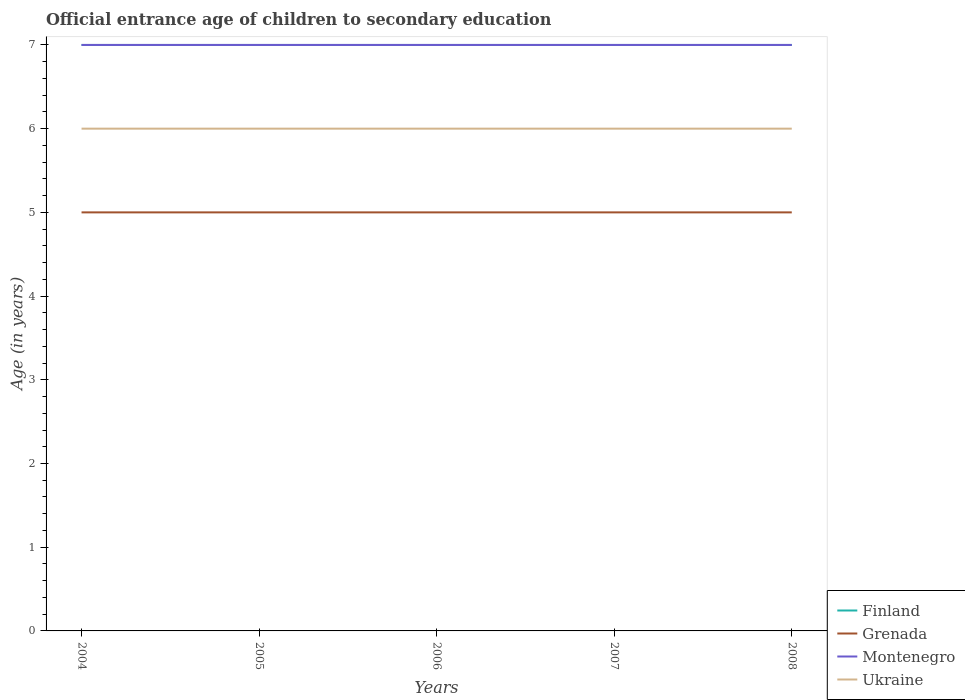How many different coloured lines are there?
Make the answer very short. 4. Across all years, what is the maximum secondary school starting age of children in Finland?
Ensure brevity in your answer.  7. What is the total secondary school starting age of children in Grenada in the graph?
Give a very brief answer. 0. What is the difference between the highest and the lowest secondary school starting age of children in Ukraine?
Ensure brevity in your answer.  0. Is the secondary school starting age of children in Ukraine strictly greater than the secondary school starting age of children in Finland over the years?
Offer a terse response. Yes. How many lines are there?
Ensure brevity in your answer.  4. Are the values on the major ticks of Y-axis written in scientific E-notation?
Your answer should be compact. No. Does the graph contain any zero values?
Ensure brevity in your answer.  No. What is the title of the graph?
Your response must be concise. Official entrance age of children to secondary education. What is the label or title of the Y-axis?
Ensure brevity in your answer.  Age (in years). What is the Age (in years) of Finland in 2004?
Your answer should be very brief. 7. What is the Age (in years) of Montenegro in 2004?
Give a very brief answer. 7. What is the Age (in years) of Grenada in 2005?
Offer a terse response. 5. What is the Age (in years) of Grenada in 2006?
Give a very brief answer. 5. What is the Age (in years) in Grenada in 2007?
Ensure brevity in your answer.  5. What is the Age (in years) of Montenegro in 2007?
Ensure brevity in your answer.  7. What is the Age (in years) in Ukraine in 2007?
Offer a very short reply. 6. What is the Age (in years) in Grenada in 2008?
Offer a terse response. 5. What is the Age (in years) of Ukraine in 2008?
Your answer should be very brief. 6. Across all years, what is the maximum Age (in years) of Grenada?
Give a very brief answer. 5. Across all years, what is the maximum Age (in years) of Montenegro?
Make the answer very short. 7. Across all years, what is the maximum Age (in years) of Ukraine?
Provide a short and direct response. 6. Across all years, what is the minimum Age (in years) of Finland?
Offer a very short reply. 7. What is the total Age (in years) in Finland in the graph?
Your answer should be compact. 35. What is the total Age (in years) in Montenegro in the graph?
Your answer should be very brief. 35. What is the difference between the Age (in years) of Grenada in 2004 and that in 2005?
Ensure brevity in your answer.  0. What is the difference between the Age (in years) in Montenegro in 2004 and that in 2005?
Your answer should be very brief. 0. What is the difference between the Age (in years) of Ukraine in 2004 and that in 2005?
Provide a short and direct response. 0. What is the difference between the Age (in years) in Finland in 2004 and that in 2006?
Provide a succinct answer. 0. What is the difference between the Age (in years) in Grenada in 2004 and that in 2006?
Make the answer very short. 0. What is the difference between the Age (in years) of Montenegro in 2004 and that in 2006?
Give a very brief answer. 0. What is the difference between the Age (in years) in Finland in 2005 and that in 2006?
Ensure brevity in your answer.  0. What is the difference between the Age (in years) in Grenada in 2005 and that in 2006?
Your answer should be compact. 0. What is the difference between the Age (in years) of Finland in 2005 and that in 2007?
Make the answer very short. 0. What is the difference between the Age (in years) of Ukraine in 2005 and that in 2007?
Your answer should be compact. 0. What is the difference between the Age (in years) of Finland in 2006 and that in 2007?
Ensure brevity in your answer.  0. What is the difference between the Age (in years) of Grenada in 2006 and that in 2007?
Your response must be concise. 0. What is the difference between the Age (in years) of Grenada in 2006 and that in 2008?
Ensure brevity in your answer.  0. What is the difference between the Age (in years) of Ukraine in 2006 and that in 2008?
Provide a short and direct response. 0. What is the difference between the Age (in years) of Finland in 2007 and that in 2008?
Ensure brevity in your answer.  0. What is the difference between the Age (in years) of Montenegro in 2007 and that in 2008?
Make the answer very short. 0. What is the difference between the Age (in years) in Finland in 2004 and the Age (in years) in Grenada in 2005?
Provide a succinct answer. 2. What is the difference between the Age (in years) of Grenada in 2004 and the Age (in years) of Ukraine in 2005?
Make the answer very short. -1. What is the difference between the Age (in years) in Grenada in 2004 and the Age (in years) in Montenegro in 2006?
Ensure brevity in your answer.  -2. What is the difference between the Age (in years) of Finland in 2004 and the Age (in years) of Grenada in 2007?
Offer a very short reply. 2. What is the difference between the Age (in years) of Montenegro in 2004 and the Age (in years) of Ukraine in 2007?
Offer a terse response. 1. What is the difference between the Age (in years) in Finland in 2004 and the Age (in years) in Grenada in 2008?
Your answer should be very brief. 2. What is the difference between the Age (in years) of Finland in 2004 and the Age (in years) of Montenegro in 2008?
Provide a succinct answer. 0. What is the difference between the Age (in years) of Finland in 2004 and the Age (in years) of Ukraine in 2008?
Make the answer very short. 1. What is the difference between the Age (in years) of Grenada in 2004 and the Age (in years) of Ukraine in 2008?
Make the answer very short. -1. What is the difference between the Age (in years) of Montenegro in 2004 and the Age (in years) of Ukraine in 2008?
Your answer should be very brief. 1. What is the difference between the Age (in years) in Grenada in 2005 and the Age (in years) in Montenegro in 2006?
Your answer should be compact. -2. What is the difference between the Age (in years) in Finland in 2005 and the Age (in years) in Grenada in 2007?
Offer a terse response. 2. What is the difference between the Age (in years) of Finland in 2005 and the Age (in years) of Montenegro in 2007?
Keep it short and to the point. 0. What is the difference between the Age (in years) of Finland in 2005 and the Age (in years) of Ukraine in 2007?
Make the answer very short. 1. What is the difference between the Age (in years) in Finland in 2005 and the Age (in years) in Montenegro in 2008?
Ensure brevity in your answer.  0. What is the difference between the Age (in years) of Finland in 2005 and the Age (in years) of Ukraine in 2008?
Provide a short and direct response. 1. What is the difference between the Age (in years) in Grenada in 2005 and the Age (in years) in Montenegro in 2008?
Give a very brief answer. -2. What is the difference between the Age (in years) of Grenada in 2005 and the Age (in years) of Ukraine in 2008?
Give a very brief answer. -1. What is the difference between the Age (in years) in Montenegro in 2005 and the Age (in years) in Ukraine in 2008?
Provide a short and direct response. 1. What is the difference between the Age (in years) in Finland in 2006 and the Age (in years) in Montenegro in 2007?
Ensure brevity in your answer.  0. What is the difference between the Age (in years) of Grenada in 2006 and the Age (in years) of Ukraine in 2007?
Provide a short and direct response. -1. What is the difference between the Age (in years) of Montenegro in 2006 and the Age (in years) of Ukraine in 2007?
Keep it short and to the point. 1. What is the difference between the Age (in years) in Finland in 2006 and the Age (in years) in Ukraine in 2008?
Keep it short and to the point. 1. What is the difference between the Age (in years) in Grenada in 2006 and the Age (in years) in Ukraine in 2008?
Keep it short and to the point. -1. What is the difference between the Age (in years) in Montenegro in 2006 and the Age (in years) in Ukraine in 2008?
Keep it short and to the point. 1. What is the difference between the Age (in years) of Finland in 2007 and the Age (in years) of Grenada in 2008?
Provide a short and direct response. 2. What is the difference between the Age (in years) of Finland in 2007 and the Age (in years) of Montenegro in 2008?
Your answer should be compact. 0. What is the difference between the Age (in years) of Grenada in 2007 and the Age (in years) of Montenegro in 2008?
Keep it short and to the point. -2. What is the difference between the Age (in years) in Grenada in 2007 and the Age (in years) in Ukraine in 2008?
Ensure brevity in your answer.  -1. What is the difference between the Age (in years) of Montenegro in 2007 and the Age (in years) of Ukraine in 2008?
Provide a succinct answer. 1. What is the average Age (in years) in Finland per year?
Ensure brevity in your answer.  7. What is the average Age (in years) of Montenegro per year?
Offer a very short reply. 7. What is the average Age (in years) of Ukraine per year?
Your answer should be compact. 6. In the year 2004, what is the difference between the Age (in years) in Finland and Age (in years) in Grenada?
Provide a succinct answer. 2. In the year 2004, what is the difference between the Age (in years) of Finland and Age (in years) of Montenegro?
Offer a very short reply. 0. In the year 2004, what is the difference between the Age (in years) of Finland and Age (in years) of Ukraine?
Give a very brief answer. 1. In the year 2004, what is the difference between the Age (in years) in Montenegro and Age (in years) in Ukraine?
Your response must be concise. 1. In the year 2005, what is the difference between the Age (in years) of Finland and Age (in years) of Ukraine?
Your response must be concise. 1. In the year 2005, what is the difference between the Age (in years) in Grenada and Age (in years) in Montenegro?
Your answer should be compact. -2. In the year 2005, what is the difference between the Age (in years) of Grenada and Age (in years) of Ukraine?
Provide a short and direct response. -1. In the year 2005, what is the difference between the Age (in years) in Montenegro and Age (in years) in Ukraine?
Provide a short and direct response. 1. In the year 2006, what is the difference between the Age (in years) in Finland and Age (in years) in Grenada?
Give a very brief answer. 2. In the year 2006, what is the difference between the Age (in years) of Finland and Age (in years) of Montenegro?
Give a very brief answer. 0. In the year 2006, what is the difference between the Age (in years) of Grenada and Age (in years) of Montenegro?
Provide a succinct answer. -2. In the year 2007, what is the difference between the Age (in years) of Finland and Age (in years) of Grenada?
Provide a succinct answer. 2. In the year 2007, what is the difference between the Age (in years) of Finland and Age (in years) of Montenegro?
Your answer should be very brief. 0. In the year 2007, what is the difference between the Age (in years) of Grenada and Age (in years) of Montenegro?
Keep it short and to the point. -2. In the year 2008, what is the difference between the Age (in years) in Finland and Age (in years) in Grenada?
Make the answer very short. 2. In the year 2008, what is the difference between the Age (in years) of Finland and Age (in years) of Montenegro?
Make the answer very short. 0. In the year 2008, what is the difference between the Age (in years) of Finland and Age (in years) of Ukraine?
Give a very brief answer. 1. In the year 2008, what is the difference between the Age (in years) of Montenegro and Age (in years) of Ukraine?
Your answer should be compact. 1. What is the ratio of the Age (in years) in Finland in 2004 to that in 2005?
Offer a very short reply. 1. What is the ratio of the Age (in years) in Montenegro in 2004 to that in 2005?
Your response must be concise. 1. What is the ratio of the Age (in years) of Grenada in 2004 to that in 2006?
Provide a succinct answer. 1. What is the ratio of the Age (in years) in Montenegro in 2004 to that in 2006?
Your answer should be compact. 1. What is the ratio of the Age (in years) in Finland in 2004 to that in 2007?
Keep it short and to the point. 1. What is the ratio of the Age (in years) of Grenada in 2004 to that in 2007?
Offer a terse response. 1. What is the ratio of the Age (in years) in Montenegro in 2004 to that in 2007?
Your answer should be compact. 1. What is the ratio of the Age (in years) of Montenegro in 2004 to that in 2008?
Provide a succinct answer. 1. What is the ratio of the Age (in years) in Ukraine in 2005 to that in 2006?
Provide a succinct answer. 1. What is the ratio of the Age (in years) in Grenada in 2005 to that in 2007?
Provide a short and direct response. 1. What is the ratio of the Age (in years) in Montenegro in 2005 to that in 2007?
Offer a very short reply. 1. What is the ratio of the Age (in years) in Finland in 2005 to that in 2008?
Give a very brief answer. 1. What is the ratio of the Age (in years) of Grenada in 2005 to that in 2008?
Your answer should be compact. 1. What is the ratio of the Age (in years) in Finland in 2006 to that in 2007?
Provide a succinct answer. 1. What is the ratio of the Age (in years) in Grenada in 2006 to that in 2007?
Provide a short and direct response. 1. What is the ratio of the Age (in years) in Ukraine in 2006 to that in 2007?
Keep it short and to the point. 1. What is the ratio of the Age (in years) of Montenegro in 2007 to that in 2008?
Make the answer very short. 1. What is the ratio of the Age (in years) in Ukraine in 2007 to that in 2008?
Ensure brevity in your answer.  1. What is the difference between the highest and the second highest Age (in years) of Finland?
Offer a very short reply. 0. What is the difference between the highest and the lowest Age (in years) of Finland?
Make the answer very short. 0. What is the difference between the highest and the lowest Age (in years) in Grenada?
Keep it short and to the point. 0. What is the difference between the highest and the lowest Age (in years) in Montenegro?
Your answer should be very brief. 0. 